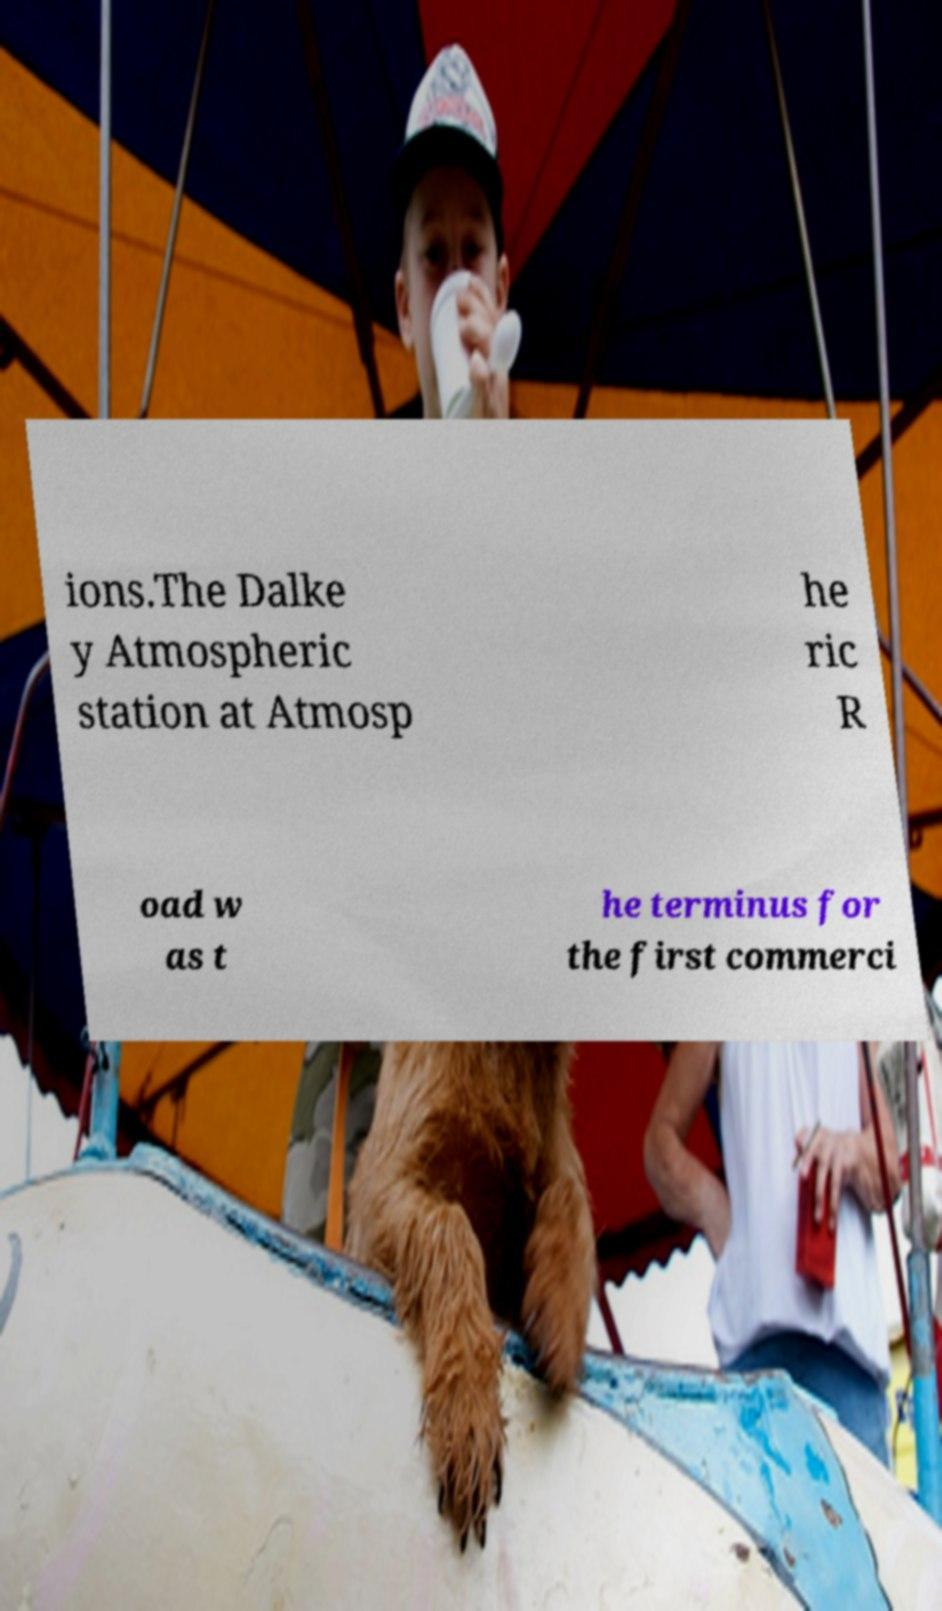Could you assist in decoding the text presented in this image and type it out clearly? ions.The Dalke y Atmospheric station at Atmosp he ric R oad w as t he terminus for the first commerci 